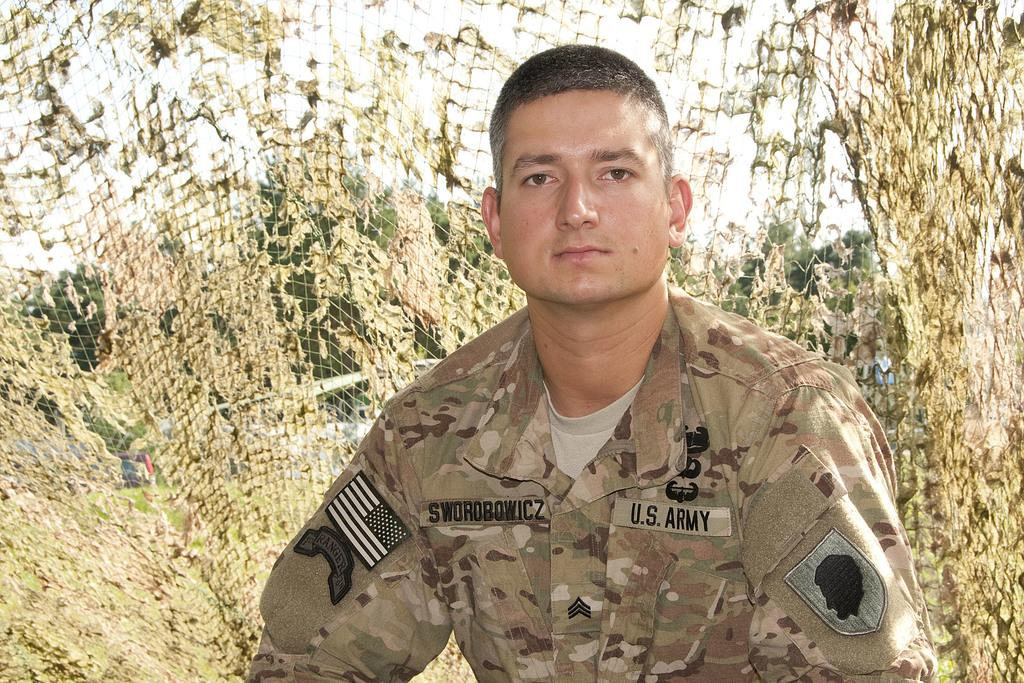Who is present in the image? There is a man in the image. What is the man wearing? The man is wearing a camouflage dress. What is behind the man in the image? The man is standing in front of a net. What type of vegetation can be seen in the image? There are trees visible in the image, and they are on a grassland. What is visible above the trees in the image? The sky is visible in the image. What type of fang can be seen in the image? There are no fangs present in the image. How many credits does the man have in the image? There is no reference to credits in the image, so it cannot be determined. 